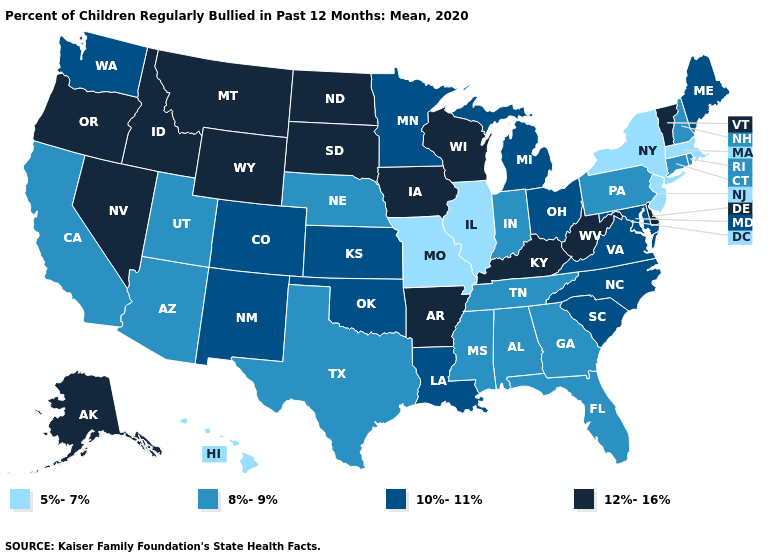What is the value of West Virginia?
Write a very short answer. 12%-16%. Does the first symbol in the legend represent the smallest category?
Quick response, please. Yes. What is the value of Colorado?
Concise answer only. 10%-11%. Among the states that border New York , does New Jersey have the highest value?
Quick response, please. No. Among the states that border Virginia , does Maryland have the lowest value?
Concise answer only. No. Which states have the lowest value in the USA?
Give a very brief answer. Hawaii, Illinois, Massachusetts, Missouri, New Jersey, New York. Among the states that border South Carolina , does Georgia have the lowest value?
Short answer required. Yes. What is the value of Mississippi?
Keep it brief. 8%-9%. Does Washington have a higher value than New York?
Give a very brief answer. Yes. Which states hav the highest value in the MidWest?
Answer briefly. Iowa, North Dakota, South Dakota, Wisconsin. Name the states that have a value in the range 12%-16%?
Concise answer only. Alaska, Arkansas, Delaware, Idaho, Iowa, Kentucky, Montana, Nevada, North Dakota, Oregon, South Dakota, Vermont, West Virginia, Wisconsin, Wyoming. Name the states that have a value in the range 8%-9%?
Keep it brief. Alabama, Arizona, California, Connecticut, Florida, Georgia, Indiana, Mississippi, Nebraska, New Hampshire, Pennsylvania, Rhode Island, Tennessee, Texas, Utah. Name the states that have a value in the range 8%-9%?
Concise answer only. Alabama, Arizona, California, Connecticut, Florida, Georgia, Indiana, Mississippi, Nebraska, New Hampshire, Pennsylvania, Rhode Island, Tennessee, Texas, Utah. Does Alabama have a higher value than Massachusetts?
Write a very short answer. Yes. 